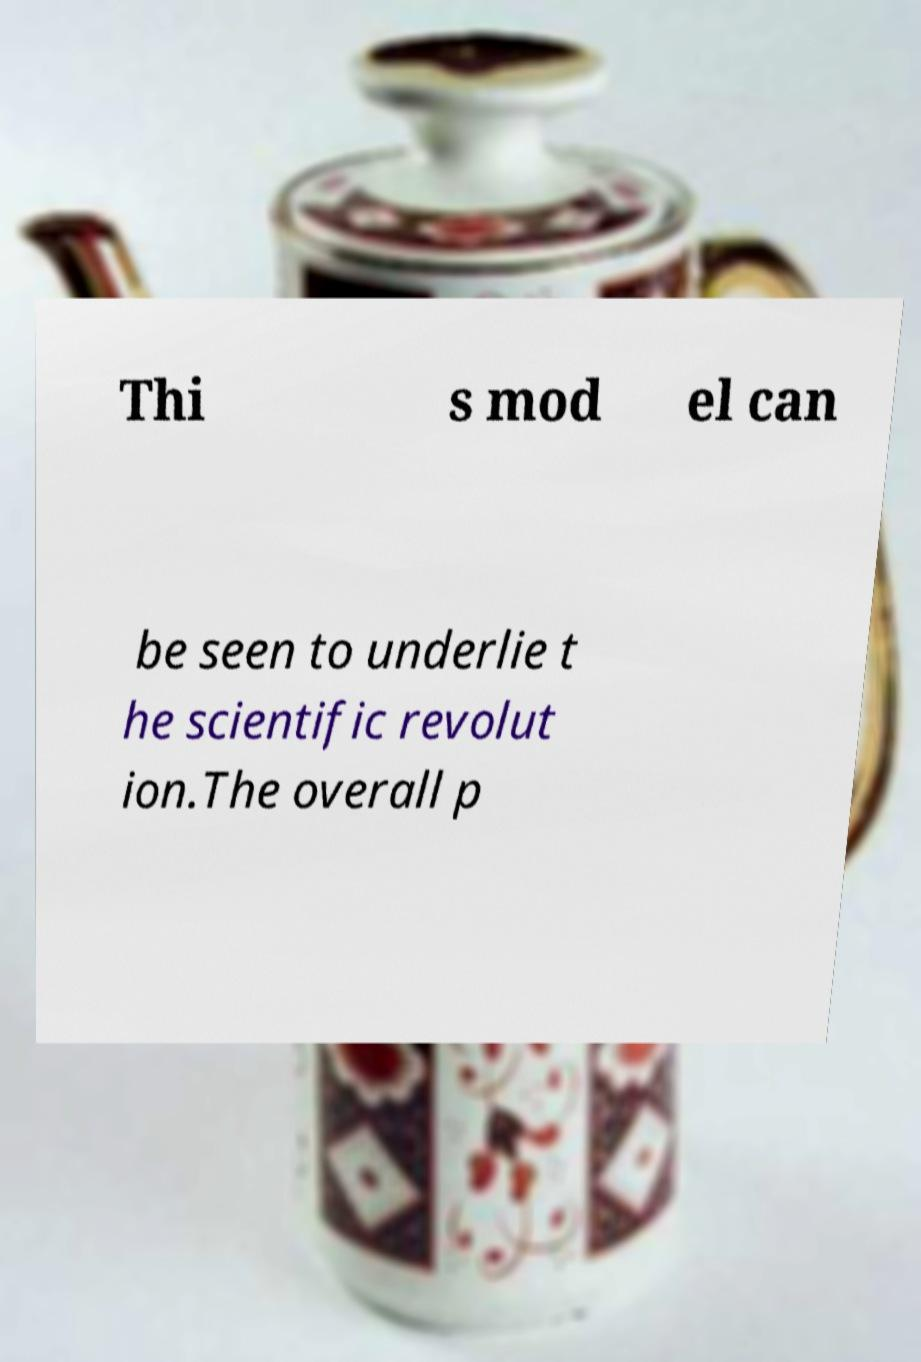Could you assist in decoding the text presented in this image and type it out clearly? Thi s mod el can be seen to underlie t he scientific revolut ion.The overall p 